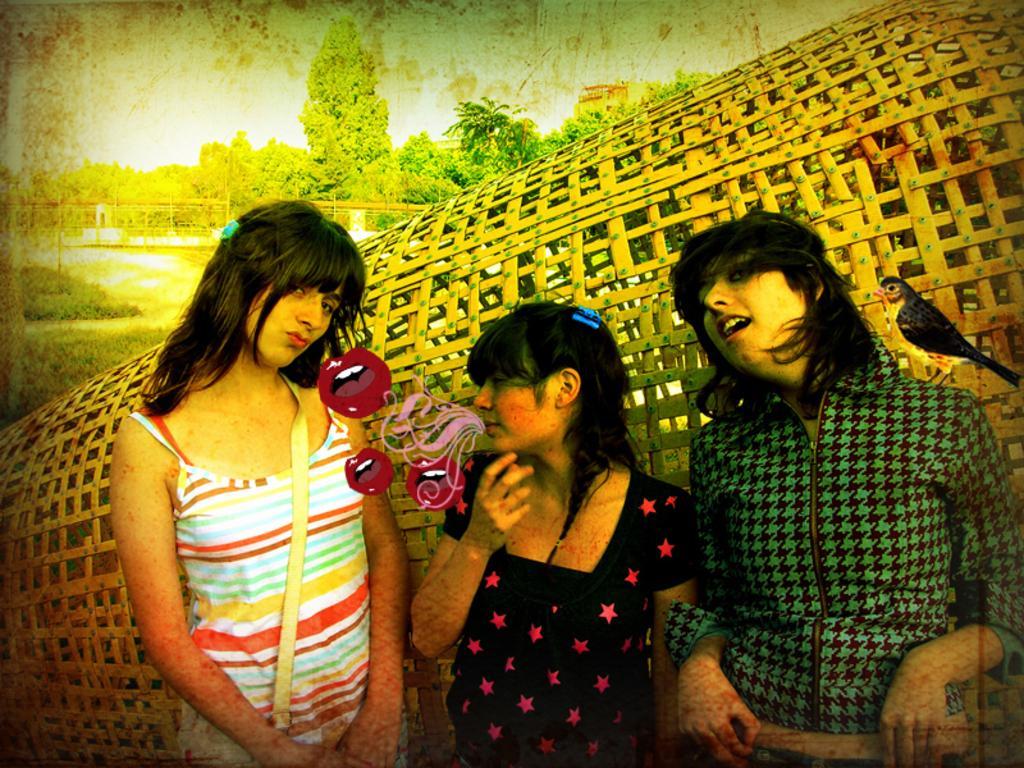Could you give a brief overview of what you see in this image? This picture is an edited picture. In this image there are three persons standing. There is a bird standing on the green jacket person. At the back there are trees behind the fence. At the top there is sky. At the bottom there is grass. There are stickers on the lips in the middle of the image. 